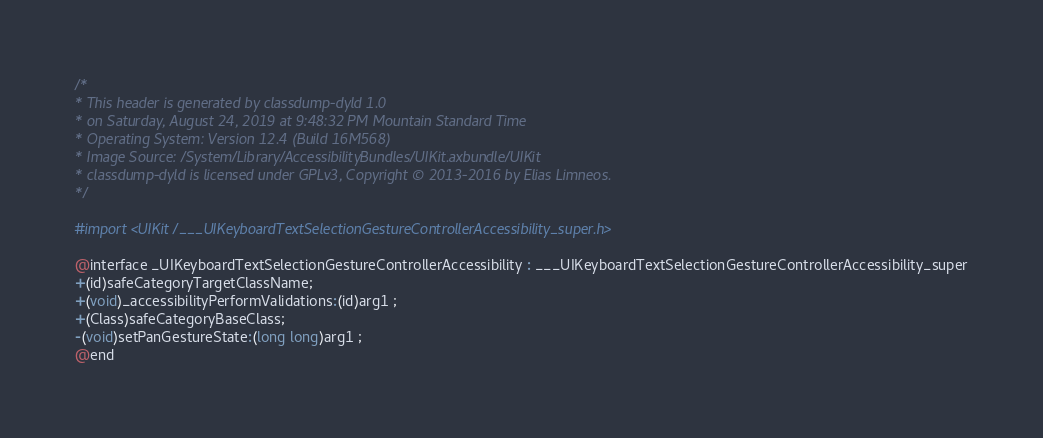<code> <loc_0><loc_0><loc_500><loc_500><_C_>/*
* This header is generated by classdump-dyld 1.0
* on Saturday, August 24, 2019 at 9:48:32 PM Mountain Standard Time
* Operating System: Version 12.4 (Build 16M568)
* Image Source: /System/Library/AccessibilityBundles/UIKit.axbundle/UIKit
* classdump-dyld is licensed under GPLv3, Copyright © 2013-2016 by Elias Limneos.
*/

#import <UIKit/___UIKeyboardTextSelectionGestureControllerAccessibility_super.h>

@interface _UIKeyboardTextSelectionGestureControllerAccessibility : ___UIKeyboardTextSelectionGestureControllerAccessibility_super
+(id)safeCategoryTargetClassName;
+(void)_accessibilityPerformValidations:(id)arg1 ;
+(Class)safeCategoryBaseClass;
-(void)setPanGestureState:(long long)arg1 ;
@end

</code> 